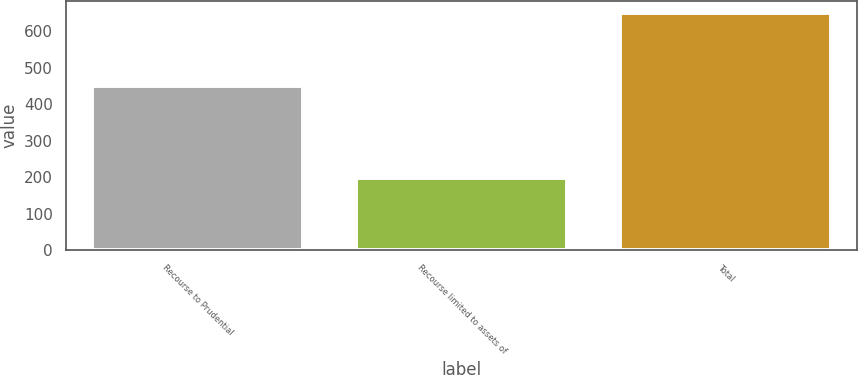<chart> <loc_0><loc_0><loc_500><loc_500><bar_chart><fcel>Recourse to Prudential<fcel>Recourse limited to assets of<fcel>Total<nl><fcel>451<fcel>198<fcel>649<nl></chart> 